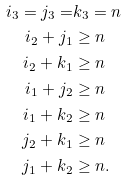Convert formula to latex. <formula><loc_0><loc_0><loc_500><loc_500>i _ { 3 } = j _ { 3 } = & k _ { 3 } = n \\ i _ { 2 } + j _ { 1 } & \geq n \\ i _ { 2 } + k _ { 1 } & \geq n \\ i _ { 1 } + j _ { 2 } & \geq n \\ i _ { 1 } + k _ { 2 } & \geq n \\ j _ { 2 } + k _ { 1 } & \geq n \\ j _ { 1 } + k _ { 2 } & \geq n .</formula> 